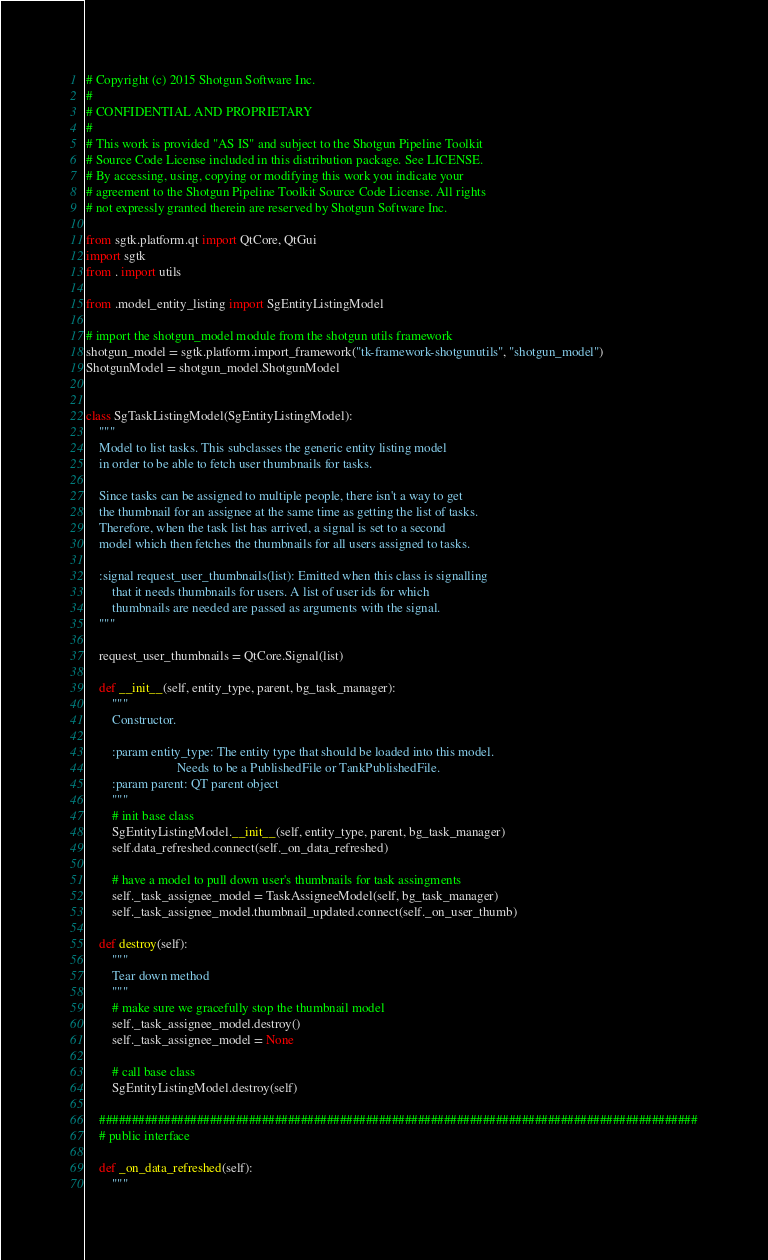Convert code to text. <code><loc_0><loc_0><loc_500><loc_500><_Python_># Copyright (c) 2015 Shotgun Software Inc.
#
# CONFIDENTIAL AND PROPRIETARY
#
# This work is provided "AS IS" and subject to the Shotgun Pipeline Toolkit
# Source Code License included in this distribution package. See LICENSE.
# By accessing, using, copying or modifying this work you indicate your
# agreement to the Shotgun Pipeline Toolkit Source Code License. All rights
# not expressly granted therein are reserved by Shotgun Software Inc.

from sgtk.platform.qt import QtCore, QtGui
import sgtk
from . import utils

from .model_entity_listing import SgEntityListingModel

# import the shotgun_model module from the shotgun utils framework
shotgun_model = sgtk.platform.import_framework("tk-framework-shotgunutils", "shotgun_model")
ShotgunModel = shotgun_model.ShotgunModel


class SgTaskListingModel(SgEntityListingModel):
    """
    Model to list tasks. This subclasses the generic entity listing model 
    in order to be able to fetch user thumbnails for tasks. 
    
    Since tasks can be assigned to multiple people, there isn't a way to get
    the thumbnail for an assignee at the same time as getting the list of tasks.
    Therefore, when the task list has arrived, a signal is set to a second
    model which then fetches the thumbnails for all users assigned to tasks.
    
    :signal request_user_thumbnails(list): Emitted when this class is signalling
        that it needs thumbnails for users. A list of user ids for which 
        thumbnails are needed are passed as arguments with the signal. 
    """
    
    request_user_thumbnails = QtCore.Signal(list)

    def __init__(self, entity_type, parent, bg_task_manager):
        """
        Constructor.
        
        :param entity_type: The entity type that should be loaded into this model.
                            Needs to be a PublishedFile or TankPublishedFile.
        :param parent: QT parent object
        """
        # init base class
        SgEntityListingModel.__init__(self, entity_type, parent, bg_task_manager)
        self.data_refreshed.connect(self._on_data_refreshed)
        
        # have a model to pull down user's thumbnails for task assingments
        self._task_assignee_model = TaskAssigneeModel(self, bg_task_manager)
        self._task_assignee_model.thumbnail_updated.connect(self._on_user_thumb)
        
    def destroy(self):
        """
        Tear down method
        """
        # make sure we gracefully stop the thumbnail model
        self._task_assignee_model.destroy()
        self._task_assignee_model = None
        
        # call base class
        SgEntityListingModel.destroy(self)
        
    ############################################################################################
    # public interface
  
    def _on_data_refreshed(self):
        """</code> 